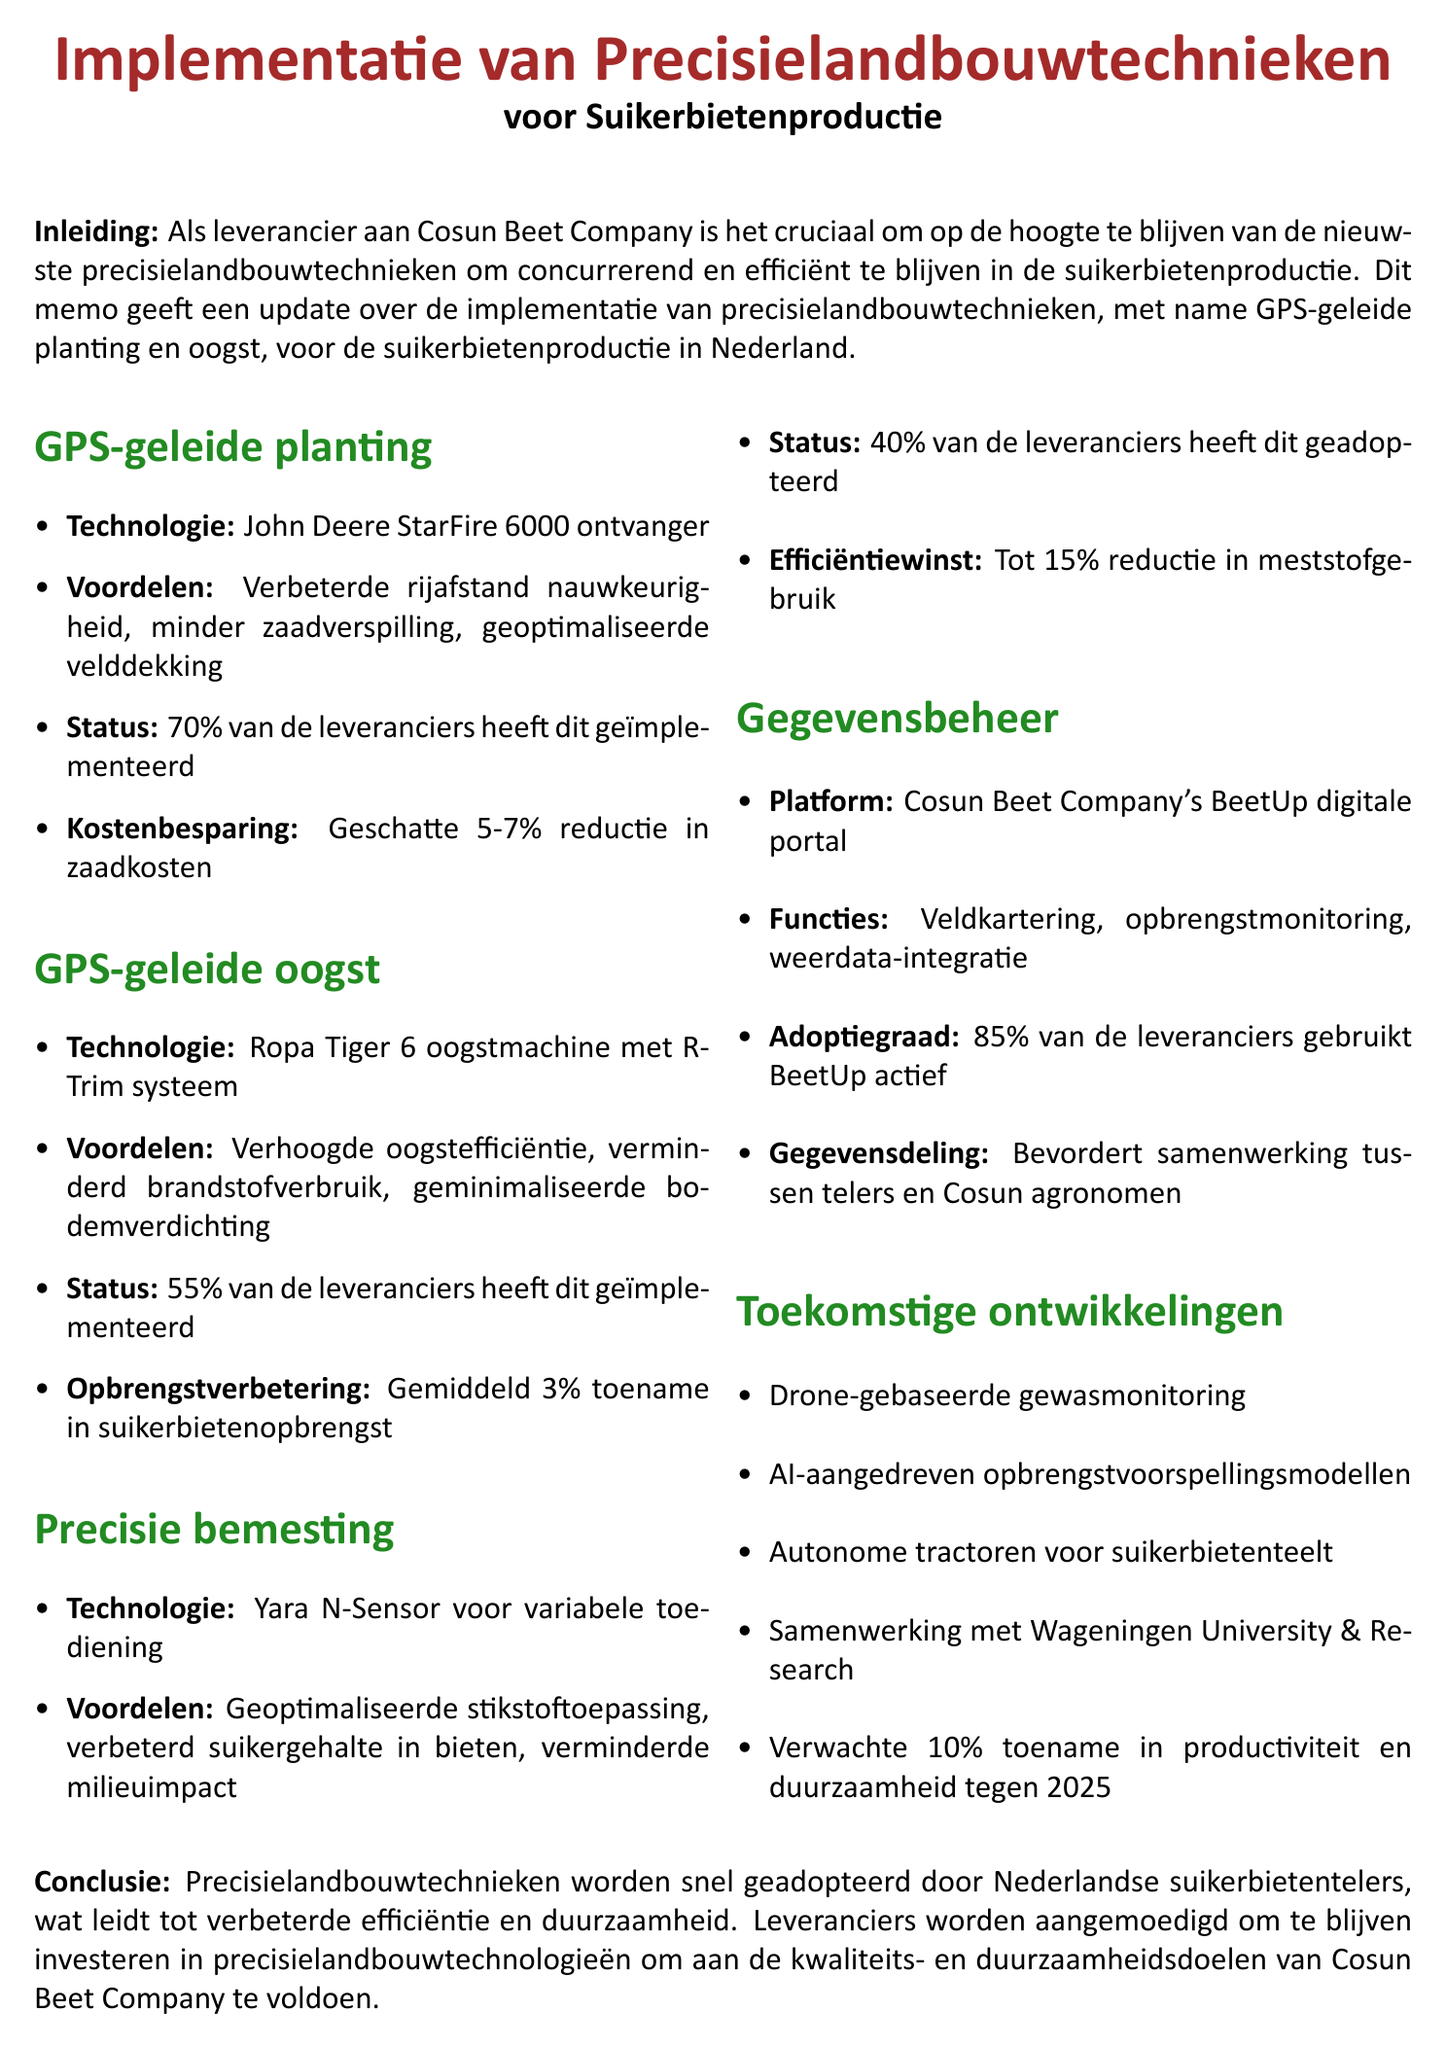What is the title of the memo? The title of the memo is found at the beginning and describes the content, which is about precision farming techniques for sugar beet production.
Answer: Implementation of Precision Farming Techniques for Sugar Beet Production What technology is used for GPS-guided planting? The memo states the specific technology that is being used for GPS-guided planting in sugar beet production.
Answer: John Deere StarFire 6000 receiver What percentage of suppliers have implemented GPS-guided harvesting? This percentage indicates the level of adoption of GPS-guided harvesting among the suppliers of Cosun Beet Company.
Answer: 55% What is the estimated cost savings from GPS-guided planting? The memo provides an estimation of the cost savings that can be achieved through GPS-guided planting techniques.
Answer: 5-7% reduction in seed costs What are the benefits of the Yara N-Sensor? The memo lists the key benefits associated with the precision fertilization technology using the Yara N-Sensor.
Answer: Optimized nitrogen application, improved sugar content in beets, reduced environmental impact What upcoming technology is mentioned for crop monitoring? This question focuses on future developments in precision farming technologies mentioned in the memo.
Answer: Drone-based crop monitoring How many features does the BeetUp digital portal have? The memo highlights the features available in the BeetUp digital portal utilized by suppliers.
Answer: Three features: Field mapping, yield monitoring, weather data integration What is the expected productivity increase by 2025 from future developments? The memo specifies the expected increase in productivity due to upcoming research initiatives and technologies.
Answer: 10% increase in productivity and sustainability 